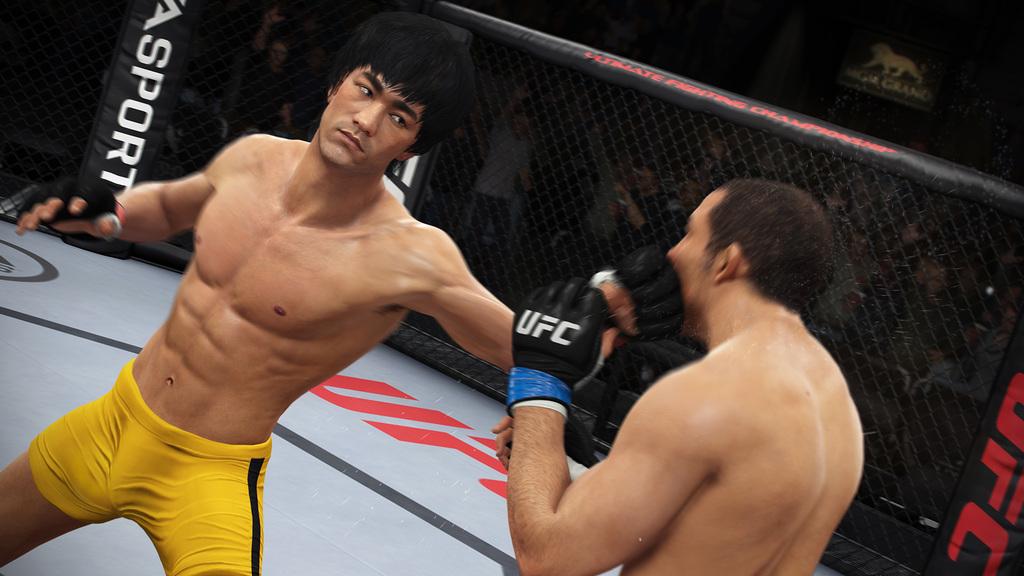What mma league is this?
Ensure brevity in your answer.  Ufc. What is on the banner on the left?
Ensure brevity in your answer.  Sport. 